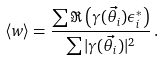<formula> <loc_0><loc_0><loc_500><loc_500>\langle w \rangle = \frac { \sum \Re \left ( \gamma ( \vec { \theta } _ { i } ) \epsilon _ { i } ^ { * } \right ) } { \sum | \gamma ( \vec { \theta } _ { i } ) | ^ { 2 } } \, .</formula> 